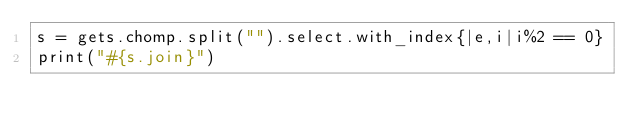<code> <loc_0><loc_0><loc_500><loc_500><_Ruby_>s = gets.chomp.split("").select.with_index{|e,i|i%2 == 0}
print("#{s.join}")</code> 